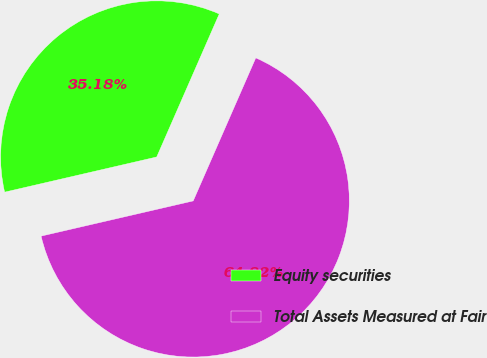Convert chart to OTSL. <chart><loc_0><loc_0><loc_500><loc_500><pie_chart><fcel>Equity securities<fcel>Total Assets Measured at Fair<nl><fcel>35.18%<fcel>64.82%<nl></chart> 